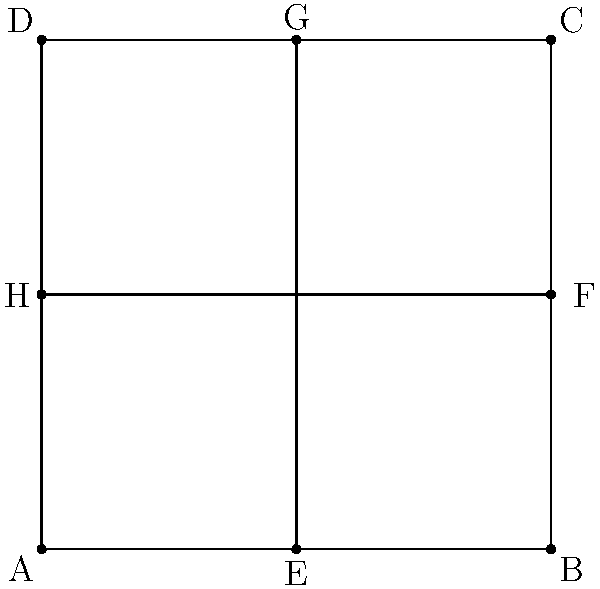In designing a symmetrical mural for Culkin's history, you've sketched a square canvas divided into four equal parts. If point E is the midpoint of side AB, and the diagonal EG is drawn, what is the measure of angle AEG? Let's approach this step-by-step:

1) The figure is a square, so all sides are equal and all angles are 90°.

2) Point E is the midpoint of AB, so AE = EB = half the side length of the square.

3) EG is a diagonal of the square, connecting midpoints of opposite sides.

4) In a square, diagonals bisect each other at right angles. This means EG is perpendicular to HF at their intersection point.

5) Triangle AEG is a right-angled triangle, with the right angle at the center of the square where EG and HF intersect.

6) In this right-angled triangle AEG:
   - AE is half the side length of the square
   - EG is half the diagonal of the square

7) In a square, the diagonal forms two 45-45-90 triangles.

8) Therefore, triangle AEG is a 45-45-90 triangle.

9) In a 45-45-90 triangle, the two non-right angles are both 45°.

Thus, angle AEG measures 45°.
Answer: 45° 